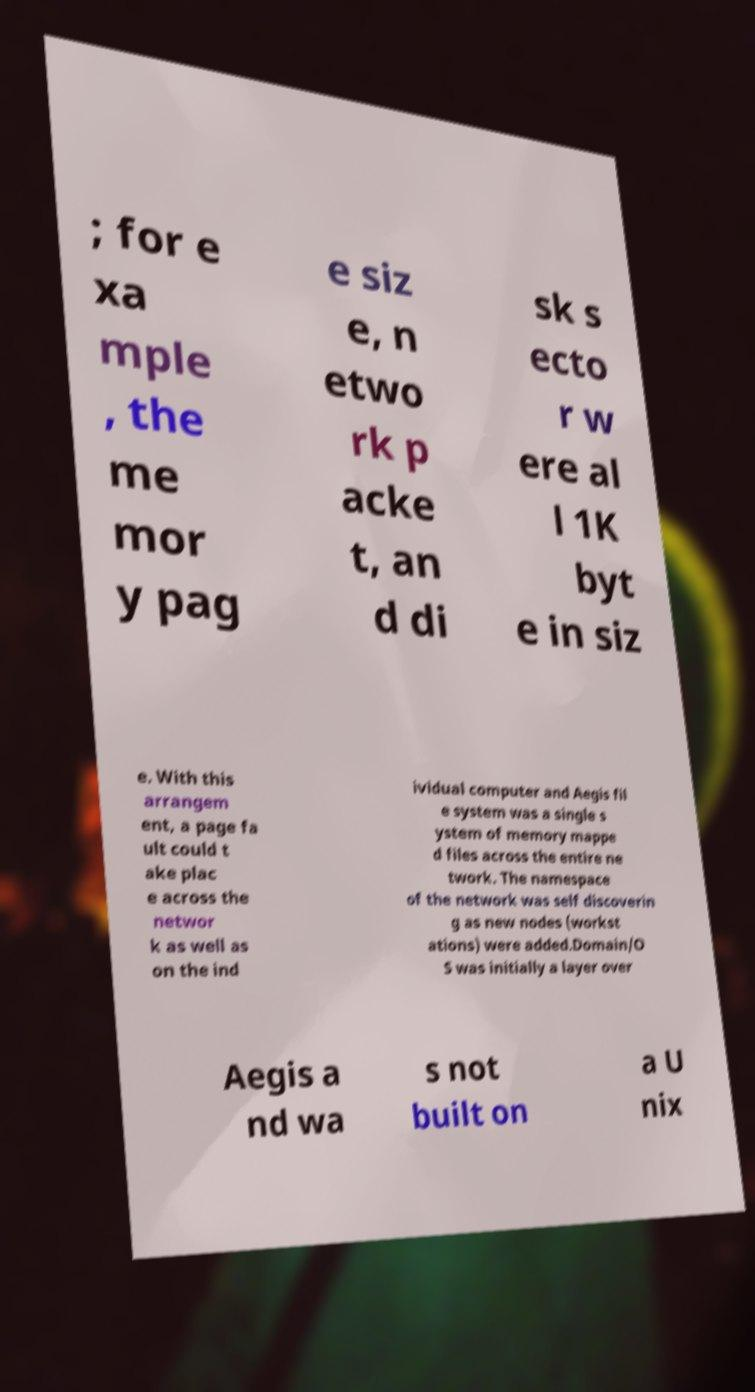Can you accurately transcribe the text from the provided image for me? ; for e xa mple , the me mor y pag e siz e, n etwo rk p acke t, an d di sk s ecto r w ere al l 1K byt e in siz e. With this arrangem ent, a page fa ult could t ake plac e across the networ k as well as on the ind ividual computer and Aegis fil e system was a single s ystem of memory mappe d files across the entire ne twork. The namespace of the network was self discoverin g as new nodes (workst ations) were added.Domain/O S was initially a layer over Aegis a nd wa s not built on a U nix 